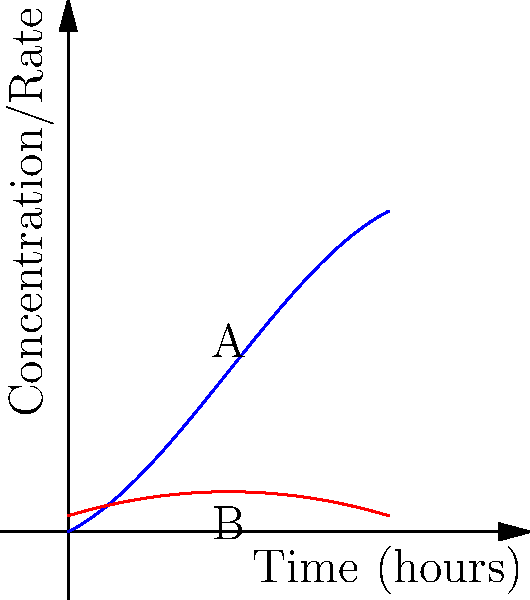The blue curve represents the concentration of a drug in the bloodstream over time, given by the function $C(t) = -0.01t^3 + 0.15t^2 + 0.5t$, where $C$ is the concentration in mg/mL and $t$ is time in hours. The red curve represents the rate of drug absorption. At what time does the absorption rate reach its maximum value, and what is this maximum rate? To solve this problem, we need to follow these steps:

1) The rate of drug absorption is represented by the derivative of the concentration function. So, we first need to find $C'(t)$:

   $C'(t) = -0.03t^2 + 0.3t + 0.5$

2) To find the maximum rate of absorption, we need to find where the derivative of $C'(t)$ equals zero:

   $C''(t) = -0.06t + 0.3$

3) Set $C''(t) = 0$ and solve for $t$:

   $-0.06t + 0.3 = 0$
   $-0.06t = -0.3$
   $t = 5$ hours

4) To confirm this is a maximum (not a minimum), we can check that $C'''(t) = -0.06 < 0$.

5) Now that we know the time of maximum absorption rate, we can calculate the rate by plugging $t=5$ into $C'(t)$:

   $C'(5) = -0.03(5)^2 + 0.3(5) + 0.5$
          $= -0.75 + 1.5 + 0.5$
          $= 1.25$ mg/mL/hour

Therefore, the absorption rate reaches its maximum value at 5 hours, and the maximum rate is 1.25 mg/mL/hour.
Answer: 5 hours; 1.25 mg/mL/hour 